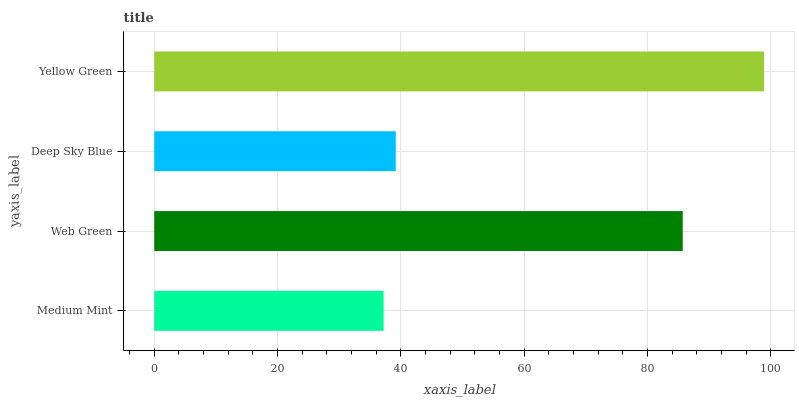Is Medium Mint the minimum?
Answer yes or no. Yes. Is Yellow Green the maximum?
Answer yes or no. Yes. Is Web Green the minimum?
Answer yes or no. No. Is Web Green the maximum?
Answer yes or no. No. Is Web Green greater than Medium Mint?
Answer yes or no. Yes. Is Medium Mint less than Web Green?
Answer yes or no. Yes. Is Medium Mint greater than Web Green?
Answer yes or no. No. Is Web Green less than Medium Mint?
Answer yes or no. No. Is Web Green the high median?
Answer yes or no. Yes. Is Deep Sky Blue the low median?
Answer yes or no. Yes. Is Yellow Green the high median?
Answer yes or no. No. Is Yellow Green the low median?
Answer yes or no. No. 